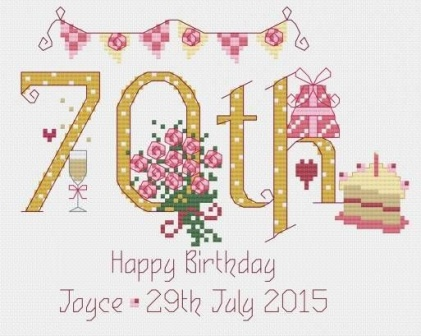What do you see happening in this image? The image presents a vibrant celebration of a 70th birthday. Dominating the scene is a banner, colored in shades of pink and white, proudly displaying the number "70th". Just below the banner, the words "Happy Birthday Joyce - 29th July 2015" are inscribed, marking a special date.

To the right of the banner, a bouquet of pink roses adds a touch of elegance to the celebration. Each rose is intricately detailed, their pink hues contrasting beautifully against the white background.

On the left of the banner, there's a slice of cake, possibly indicating a birthday celebration. The cake, with its layers visible, seems ready to be savored.

The entire scene is set against a white background, which allows the pink, white, and yellow colors of the objects to stand out. The positioning of the objects and the text suggests a well-planned and joyous celebration of a significant milestone. The image, in its entirety, captures a moment of joy and celebration, frozen in time for posterity. 